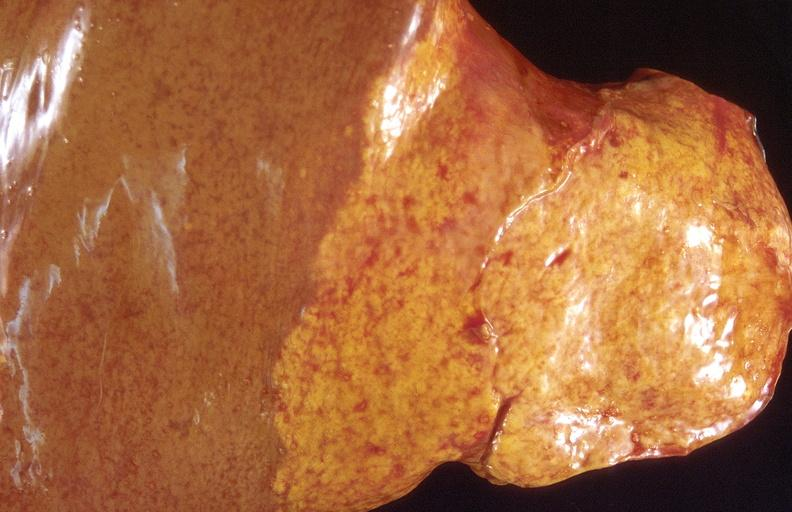what is present?
Answer the question using a single word or phrase. Hepatobiliary 